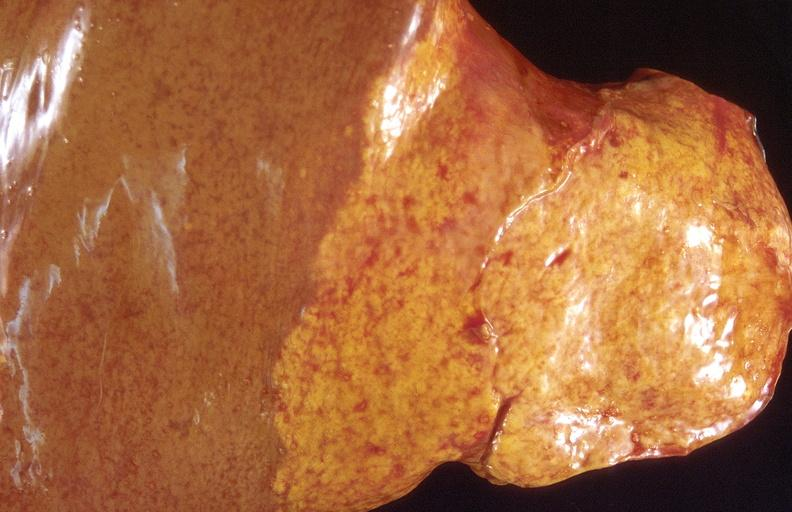what is present?
Answer the question using a single word or phrase. Hepatobiliary 